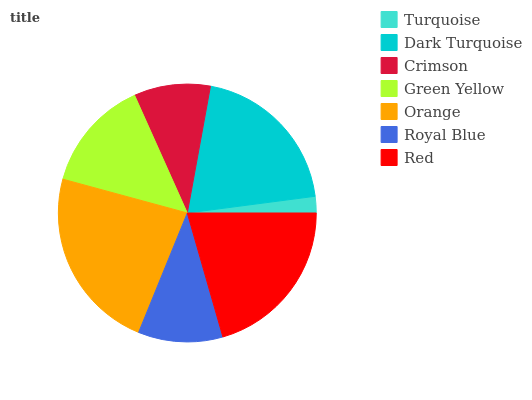Is Turquoise the minimum?
Answer yes or no. Yes. Is Orange the maximum?
Answer yes or no. Yes. Is Dark Turquoise the minimum?
Answer yes or no. No. Is Dark Turquoise the maximum?
Answer yes or no. No. Is Dark Turquoise greater than Turquoise?
Answer yes or no. Yes. Is Turquoise less than Dark Turquoise?
Answer yes or no. Yes. Is Turquoise greater than Dark Turquoise?
Answer yes or no. No. Is Dark Turquoise less than Turquoise?
Answer yes or no. No. Is Green Yellow the high median?
Answer yes or no. Yes. Is Green Yellow the low median?
Answer yes or no. Yes. Is Red the high median?
Answer yes or no. No. Is Red the low median?
Answer yes or no. No. 